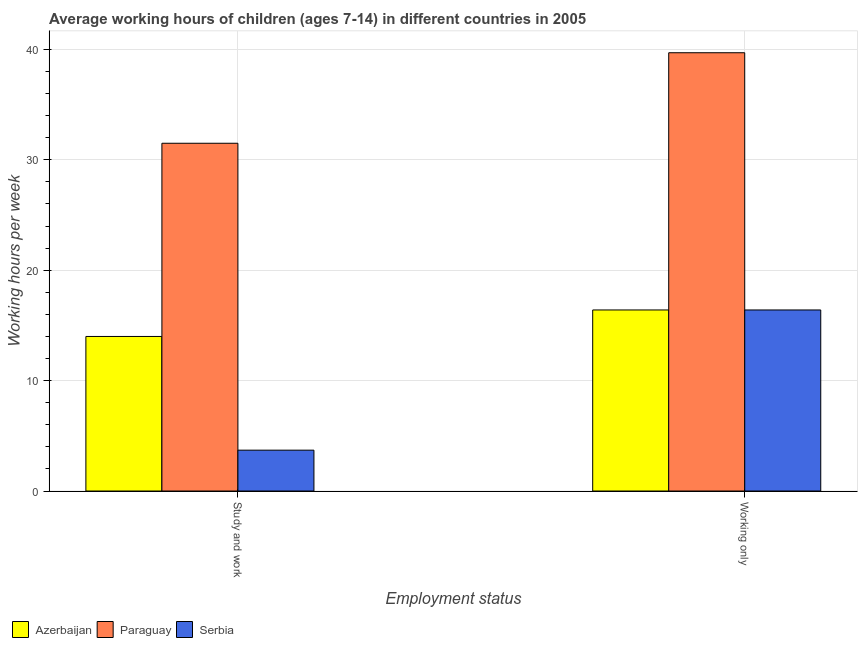How many groups of bars are there?
Provide a short and direct response. 2. Are the number of bars per tick equal to the number of legend labels?
Provide a short and direct response. Yes. Are the number of bars on each tick of the X-axis equal?
Provide a succinct answer. Yes. How many bars are there on the 2nd tick from the left?
Your answer should be compact. 3. What is the label of the 2nd group of bars from the left?
Ensure brevity in your answer.  Working only. What is the average working hour of children involved in only work in Azerbaijan?
Make the answer very short. 16.4. Across all countries, what is the maximum average working hour of children involved in study and work?
Provide a succinct answer. 31.5. Across all countries, what is the minimum average working hour of children involved in study and work?
Your answer should be compact. 3.7. In which country was the average working hour of children involved in study and work maximum?
Your response must be concise. Paraguay. In which country was the average working hour of children involved in only work minimum?
Offer a terse response. Azerbaijan. What is the total average working hour of children involved in study and work in the graph?
Provide a short and direct response. 49.2. What is the difference between the average working hour of children involved in study and work in Serbia and the average working hour of children involved in only work in Azerbaijan?
Your answer should be compact. -12.7. What is the average average working hour of children involved in only work per country?
Your answer should be very brief. 24.17. What is the difference between the average working hour of children involved in study and work and average working hour of children involved in only work in Paraguay?
Your answer should be very brief. -8.2. What is the ratio of the average working hour of children involved in study and work in Serbia to that in Azerbaijan?
Provide a short and direct response. 0.26. In how many countries, is the average working hour of children involved in only work greater than the average average working hour of children involved in only work taken over all countries?
Ensure brevity in your answer.  1. What does the 2nd bar from the left in Study and work represents?
Offer a terse response. Paraguay. What does the 1st bar from the right in Study and work represents?
Your response must be concise. Serbia. Does the graph contain any zero values?
Your response must be concise. No. Where does the legend appear in the graph?
Offer a terse response. Bottom left. How many legend labels are there?
Keep it short and to the point. 3. How are the legend labels stacked?
Offer a terse response. Horizontal. What is the title of the graph?
Offer a terse response. Average working hours of children (ages 7-14) in different countries in 2005. What is the label or title of the X-axis?
Your response must be concise. Employment status. What is the label or title of the Y-axis?
Your answer should be very brief. Working hours per week. What is the Working hours per week of Paraguay in Study and work?
Your answer should be compact. 31.5. What is the Working hours per week of Serbia in Study and work?
Make the answer very short. 3.7. What is the Working hours per week of Azerbaijan in Working only?
Your response must be concise. 16.4. What is the Working hours per week of Paraguay in Working only?
Keep it short and to the point. 39.7. Across all Employment status, what is the maximum Working hours per week in Paraguay?
Your answer should be compact. 39.7. Across all Employment status, what is the maximum Working hours per week of Serbia?
Offer a very short reply. 16.4. Across all Employment status, what is the minimum Working hours per week in Paraguay?
Offer a terse response. 31.5. Across all Employment status, what is the minimum Working hours per week of Serbia?
Offer a very short reply. 3.7. What is the total Working hours per week of Azerbaijan in the graph?
Your answer should be compact. 30.4. What is the total Working hours per week of Paraguay in the graph?
Ensure brevity in your answer.  71.2. What is the total Working hours per week in Serbia in the graph?
Provide a succinct answer. 20.1. What is the difference between the Working hours per week of Paraguay in Study and work and that in Working only?
Make the answer very short. -8.2. What is the difference between the Working hours per week in Serbia in Study and work and that in Working only?
Provide a short and direct response. -12.7. What is the difference between the Working hours per week of Azerbaijan in Study and work and the Working hours per week of Paraguay in Working only?
Offer a terse response. -25.7. What is the difference between the Working hours per week of Paraguay in Study and work and the Working hours per week of Serbia in Working only?
Offer a terse response. 15.1. What is the average Working hours per week in Azerbaijan per Employment status?
Your answer should be very brief. 15.2. What is the average Working hours per week in Paraguay per Employment status?
Make the answer very short. 35.6. What is the average Working hours per week in Serbia per Employment status?
Provide a succinct answer. 10.05. What is the difference between the Working hours per week in Azerbaijan and Working hours per week in Paraguay in Study and work?
Ensure brevity in your answer.  -17.5. What is the difference between the Working hours per week of Paraguay and Working hours per week of Serbia in Study and work?
Your response must be concise. 27.8. What is the difference between the Working hours per week of Azerbaijan and Working hours per week of Paraguay in Working only?
Make the answer very short. -23.3. What is the difference between the Working hours per week of Azerbaijan and Working hours per week of Serbia in Working only?
Ensure brevity in your answer.  0. What is the difference between the Working hours per week of Paraguay and Working hours per week of Serbia in Working only?
Provide a succinct answer. 23.3. What is the ratio of the Working hours per week in Azerbaijan in Study and work to that in Working only?
Provide a short and direct response. 0.85. What is the ratio of the Working hours per week in Paraguay in Study and work to that in Working only?
Your response must be concise. 0.79. What is the ratio of the Working hours per week of Serbia in Study and work to that in Working only?
Ensure brevity in your answer.  0.23. What is the difference between the highest and the second highest Working hours per week of Azerbaijan?
Offer a terse response. 2.4. What is the difference between the highest and the second highest Working hours per week in Paraguay?
Give a very brief answer. 8.2. 